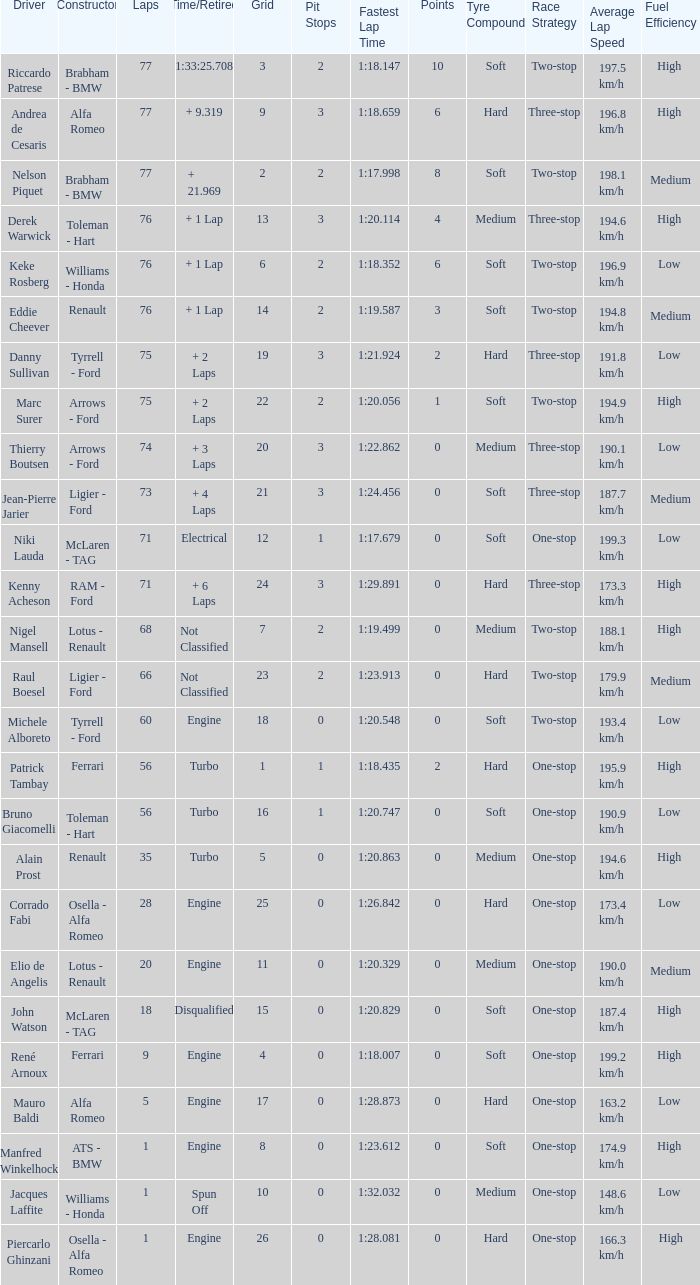Who drive the car that went under 60 laps and spun off? Jacques Laffite. 